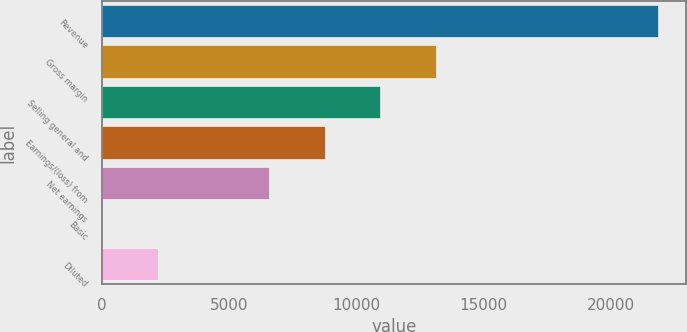Convert chart to OTSL. <chart><loc_0><loc_0><loc_500><loc_500><bar_chart><fcel>Revenue<fcel>Gross margin<fcel>Selling general and<fcel>Earnings/(loss) from<fcel>Net earnings<fcel>Basic<fcel>Diluted<nl><fcel>21867.1<fcel>13120.3<fcel>10933.6<fcel>8746.85<fcel>6560.14<fcel>0.01<fcel>2186.72<nl></chart> 